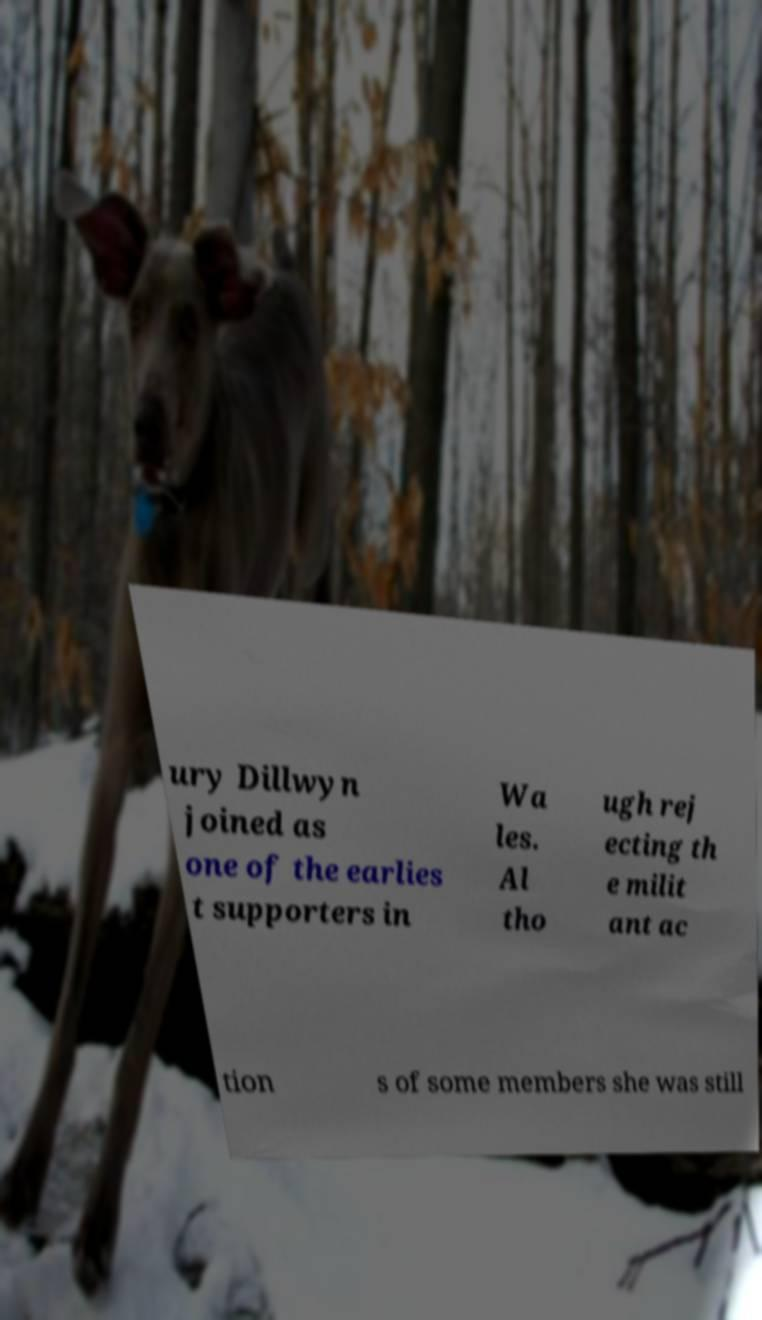What messages or text are displayed in this image? I need them in a readable, typed format. ury Dillwyn joined as one of the earlies t supporters in Wa les. Al tho ugh rej ecting th e milit ant ac tion s of some members she was still 